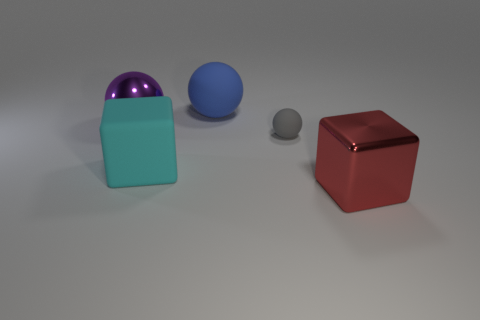How many other things are there of the same color as the metallic cube?
Offer a terse response. 0. Are there more red objects than big cyan metal blocks?
Your answer should be very brief. Yes. What material is the big cyan cube?
Offer a terse response. Rubber. Do the shiny object on the left side of the red cube and the small gray rubber sphere have the same size?
Give a very brief answer. No. There is a shiny thing on the right side of the big cyan rubber object; what size is it?
Make the answer very short. Large. Is there any other thing that has the same material as the blue object?
Provide a succinct answer. Yes. What number of gray matte cubes are there?
Keep it short and to the point. 0. Do the metallic block and the large rubber cube have the same color?
Offer a terse response. No. What color is the thing that is both on the right side of the large cyan object and in front of the tiny ball?
Provide a succinct answer. Red. There is a red metallic object; are there any large objects behind it?
Make the answer very short. Yes. 